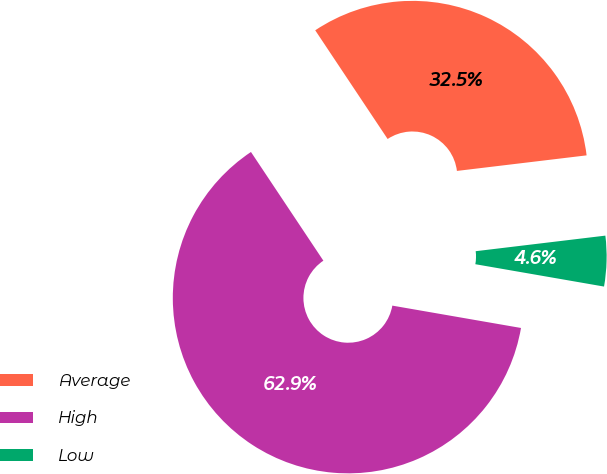Convert chart to OTSL. <chart><loc_0><loc_0><loc_500><loc_500><pie_chart><fcel>Average<fcel>High<fcel>Low<nl><fcel>32.45%<fcel>62.91%<fcel>4.64%<nl></chart> 